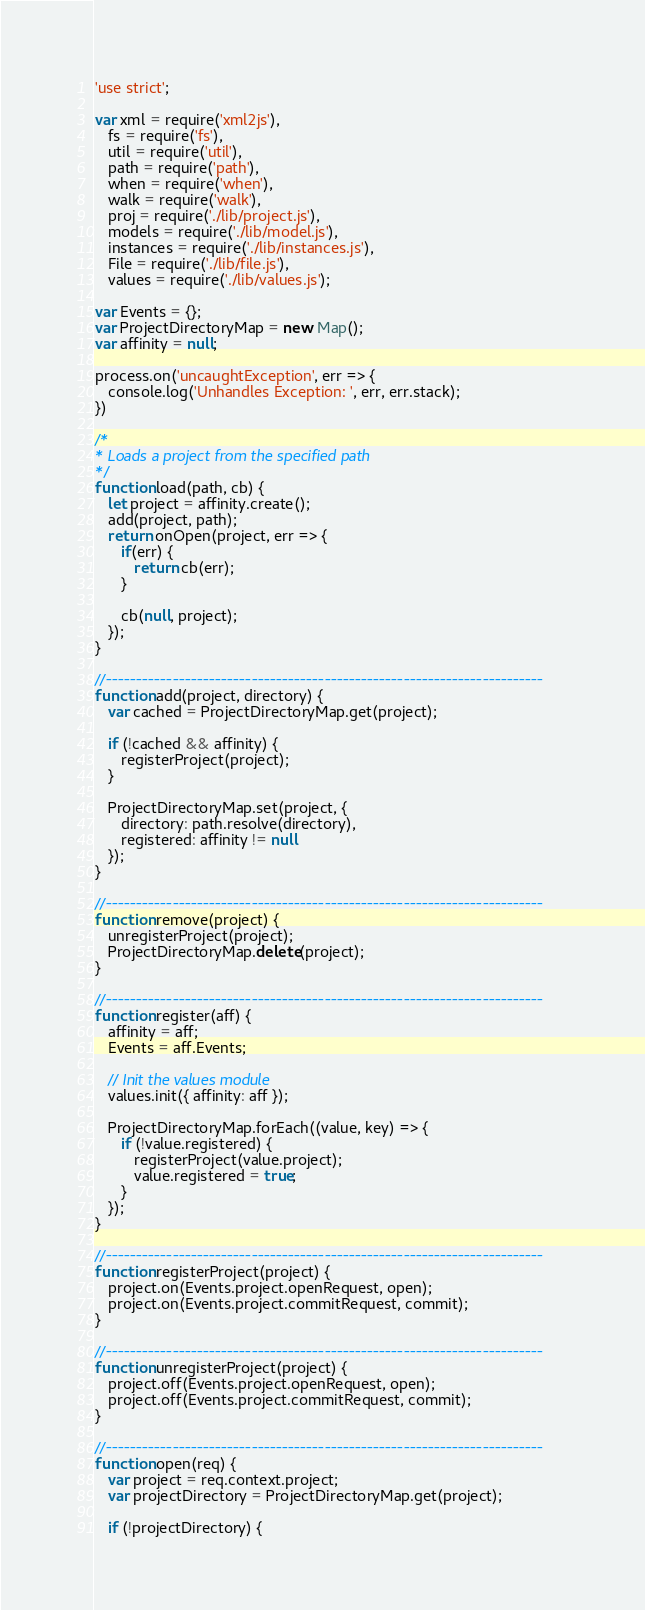Convert code to text. <code><loc_0><loc_0><loc_500><loc_500><_JavaScript_>'use strict';

var xml = require('xml2js'),
   fs = require('fs'),
   util = require('util'),
   path = require('path'),
   when = require('when'),
   walk = require('walk'),
   proj = require('./lib/project.js'),
   models = require('./lib/model.js'),
   instances = require('./lib/instances.js'),
   File = require('./lib/file.js'),
   values = require('./lib/values.js');

var Events = {};
var ProjectDirectoryMap = new Map();
var affinity = null;

process.on('uncaughtException', err => {
   console.log('Unhandles Exception: ', err, err.stack);
}) 

/*
* Loads a project from the specified path
*/
function load(path, cb) {
   let project = affinity.create();
   add(project, path);
   return onOpen(project, err => {
      if(err) {
         return cb(err);
      }

      cb(null, project);
   });
}

//------------------------------------------------------------------------
function add(project, directory) {
   var cached = ProjectDirectoryMap.get(project);

   if (!cached && affinity) {
      registerProject(project);
   }

   ProjectDirectoryMap.set(project, {
      directory: path.resolve(directory),
      registered: affinity != null
   });
}

//------------------------------------------------------------------------
function remove(project) {
   unregisterProject(project);
   ProjectDirectoryMap.delete(project);
}

//------------------------------------------------------------------------
function register(aff) {
   affinity = aff;
   Events = aff.Events;

   // Init the values module
   values.init({ affinity: aff });

   ProjectDirectoryMap.forEach((value, key) => {
      if (!value.registered) {
         registerProject(value.project);
         value.registered = true;
      }
   });
}

//------------------------------------------------------------------------
function registerProject(project) {
   project.on(Events.project.openRequest, open);
   project.on(Events.project.commitRequest, commit);
}

//------------------------------------------------------------------------
function unregisterProject(project) {
   project.off(Events.project.openRequest, open);
   project.off(Events.project.commitRequest, commit);
}

//------------------------------------------------------------------------
function open(req) {
   var project = req.context.project;
   var projectDirectory = ProjectDirectoryMap.get(project);

   if (!projectDirectory) {</code> 